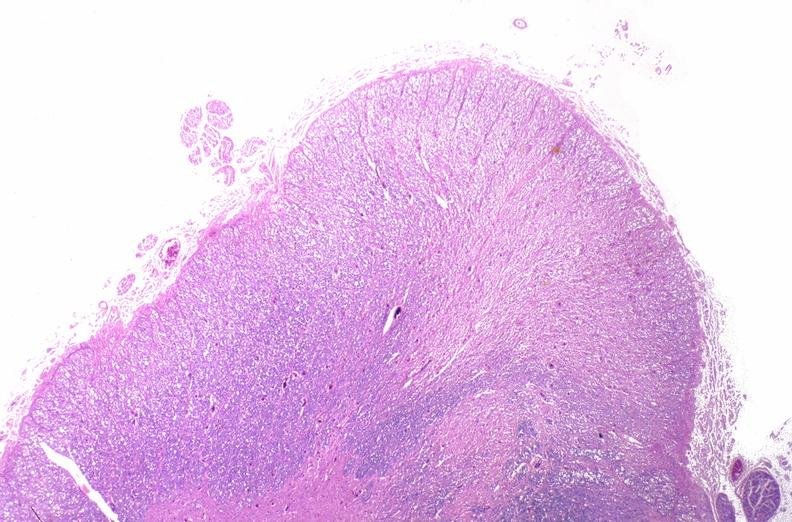does cortical nodule show spinal cord injury due to vertebral column trauma, demyelination?
Answer the question using a single word or phrase. No 